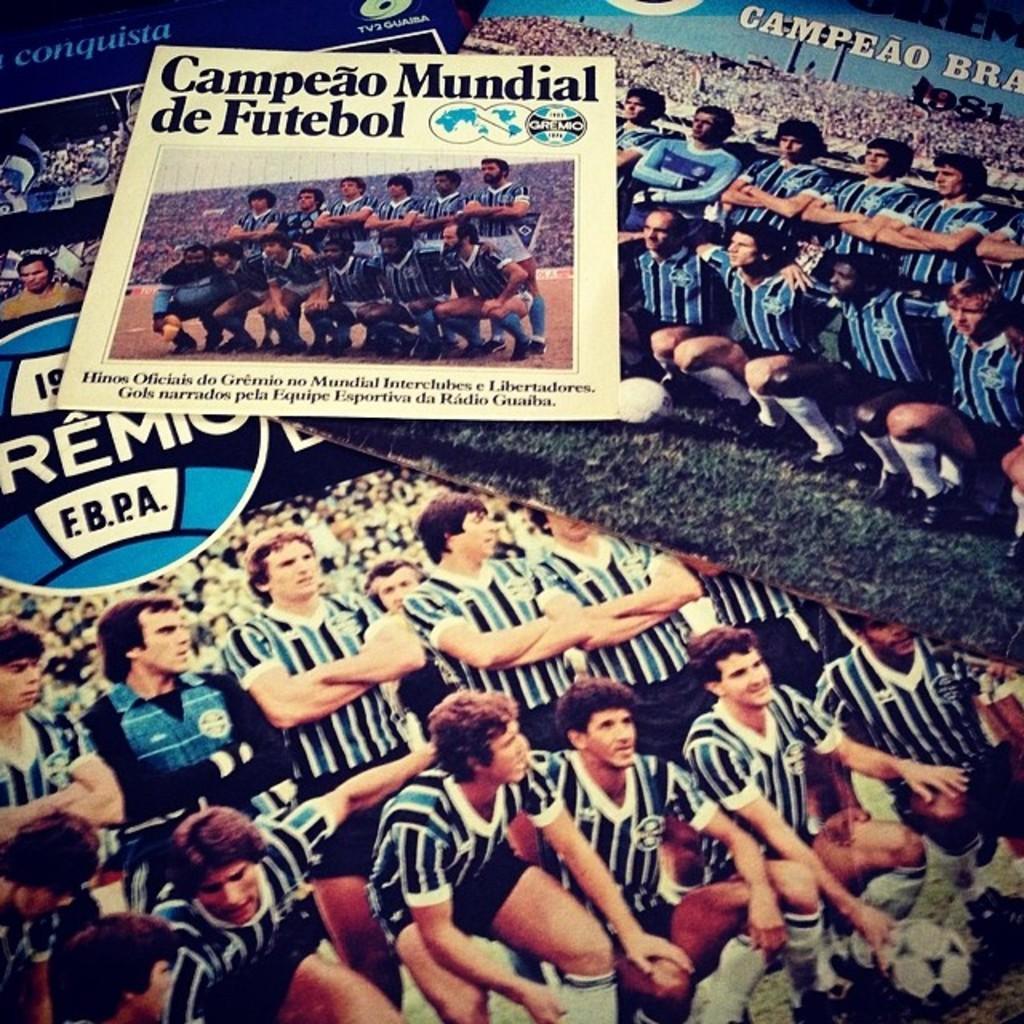Could you give a brief overview of what you see in this image? In this picture we can see posts, in these posters we can see people and some information. 